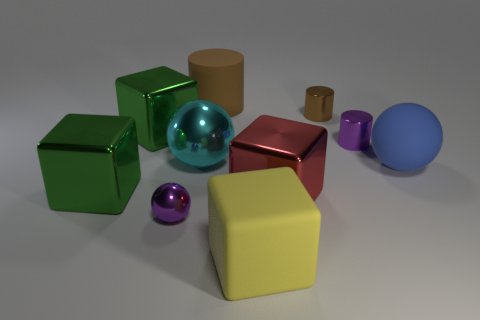Subtract all brown blocks. Subtract all purple balls. How many blocks are left? 4 Subtract all cubes. How many objects are left? 6 Subtract 0 purple cubes. How many objects are left? 10 Subtract all tiny blue rubber balls. Subtract all tiny metal spheres. How many objects are left? 9 Add 5 large blue objects. How many large blue objects are left? 6 Add 2 spheres. How many spheres exist? 5 